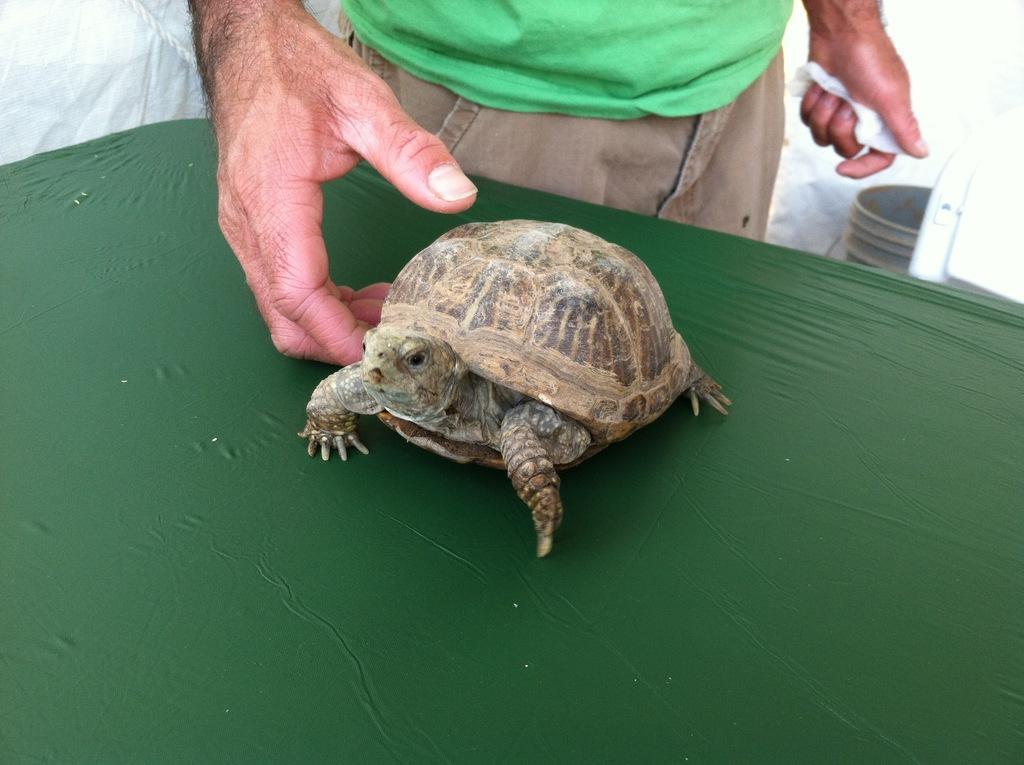How would you summarize this image in a sentence or two? This is a tortoise, which is placed on the table. This table is dark green in color. Here is a person standing. This looks like a bucket. The background looks white in color. 